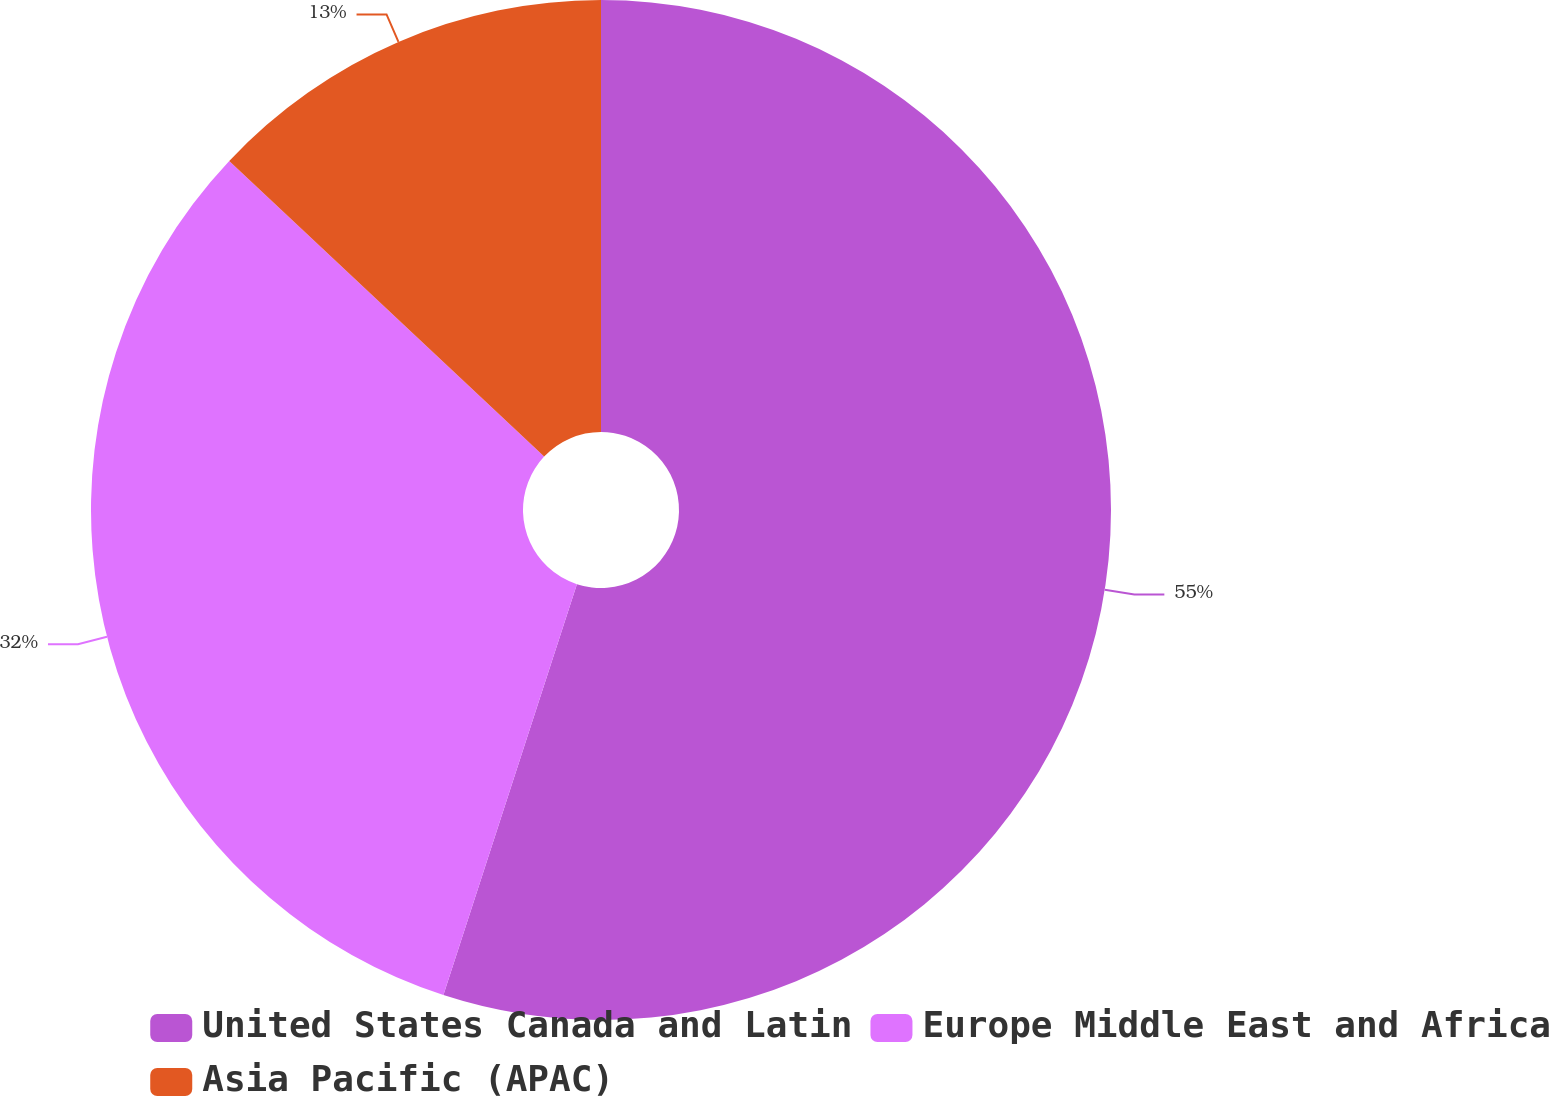Convert chart. <chart><loc_0><loc_0><loc_500><loc_500><pie_chart><fcel>United States Canada and Latin<fcel>Europe Middle East and Africa<fcel>Asia Pacific (APAC)<nl><fcel>55.0%<fcel>32.0%<fcel>13.0%<nl></chart> 